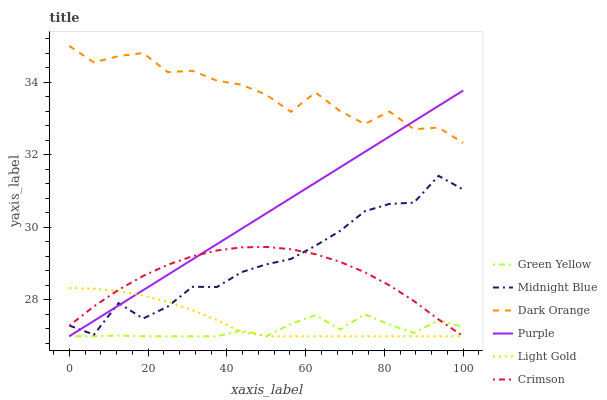Does Green Yellow have the minimum area under the curve?
Answer yes or no. Yes. Does Dark Orange have the maximum area under the curve?
Answer yes or no. Yes. Does Midnight Blue have the minimum area under the curve?
Answer yes or no. No. Does Midnight Blue have the maximum area under the curve?
Answer yes or no. No. Is Purple the smoothest?
Answer yes or no. Yes. Is Dark Orange the roughest?
Answer yes or no. Yes. Is Midnight Blue the smoothest?
Answer yes or no. No. Is Midnight Blue the roughest?
Answer yes or no. No. Does Midnight Blue have the lowest value?
Answer yes or no. No. Does Midnight Blue have the highest value?
Answer yes or no. No. Is Midnight Blue less than Dark Orange?
Answer yes or no. Yes. Is Dark Orange greater than Light Gold?
Answer yes or no. Yes. Does Midnight Blue intersect Dark Orange?
Answer yes or no. No. 